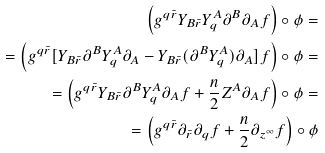Convert formula to latex. <formula><loc_0><loc_0><loc_500><loc_500>\left ( g ^ { q \bar { r } } Y _ { B \bar { r } } Y ^ { A } _ { q } \partial ^ { B } \partial _ { A } f \right ) \circ \phi = \\ = \left ( g ^ { q \bar { r } } [ Y _ { B \bar { r } } \partial ^ { B } Y ^ { A } _ { q } \partial _ { A } - Y _ { B \bar { r } } ( \partial ^ { B } Y ^ { A } _ { q } ) \partial _ { A } ] f \right ) \circ \phi = \\ = \left ( g ^ { q \bar { r } } Y _ { B \bar { r } } \partial ^ { B } Y ^ { A } _ { q } \partial _ { A } f + \frac { n } { 2 } Z ^ { A } \partial _ { A } f \right ) \circ \phi = \\ = \left ( g ^ { q \bar { r } } \partial _ { \bar { r } } \partial _ { q } f + \frac { n } { 2 } \partial _ { z ^ { \infty } } f \right ) \circ \phi</formula> 